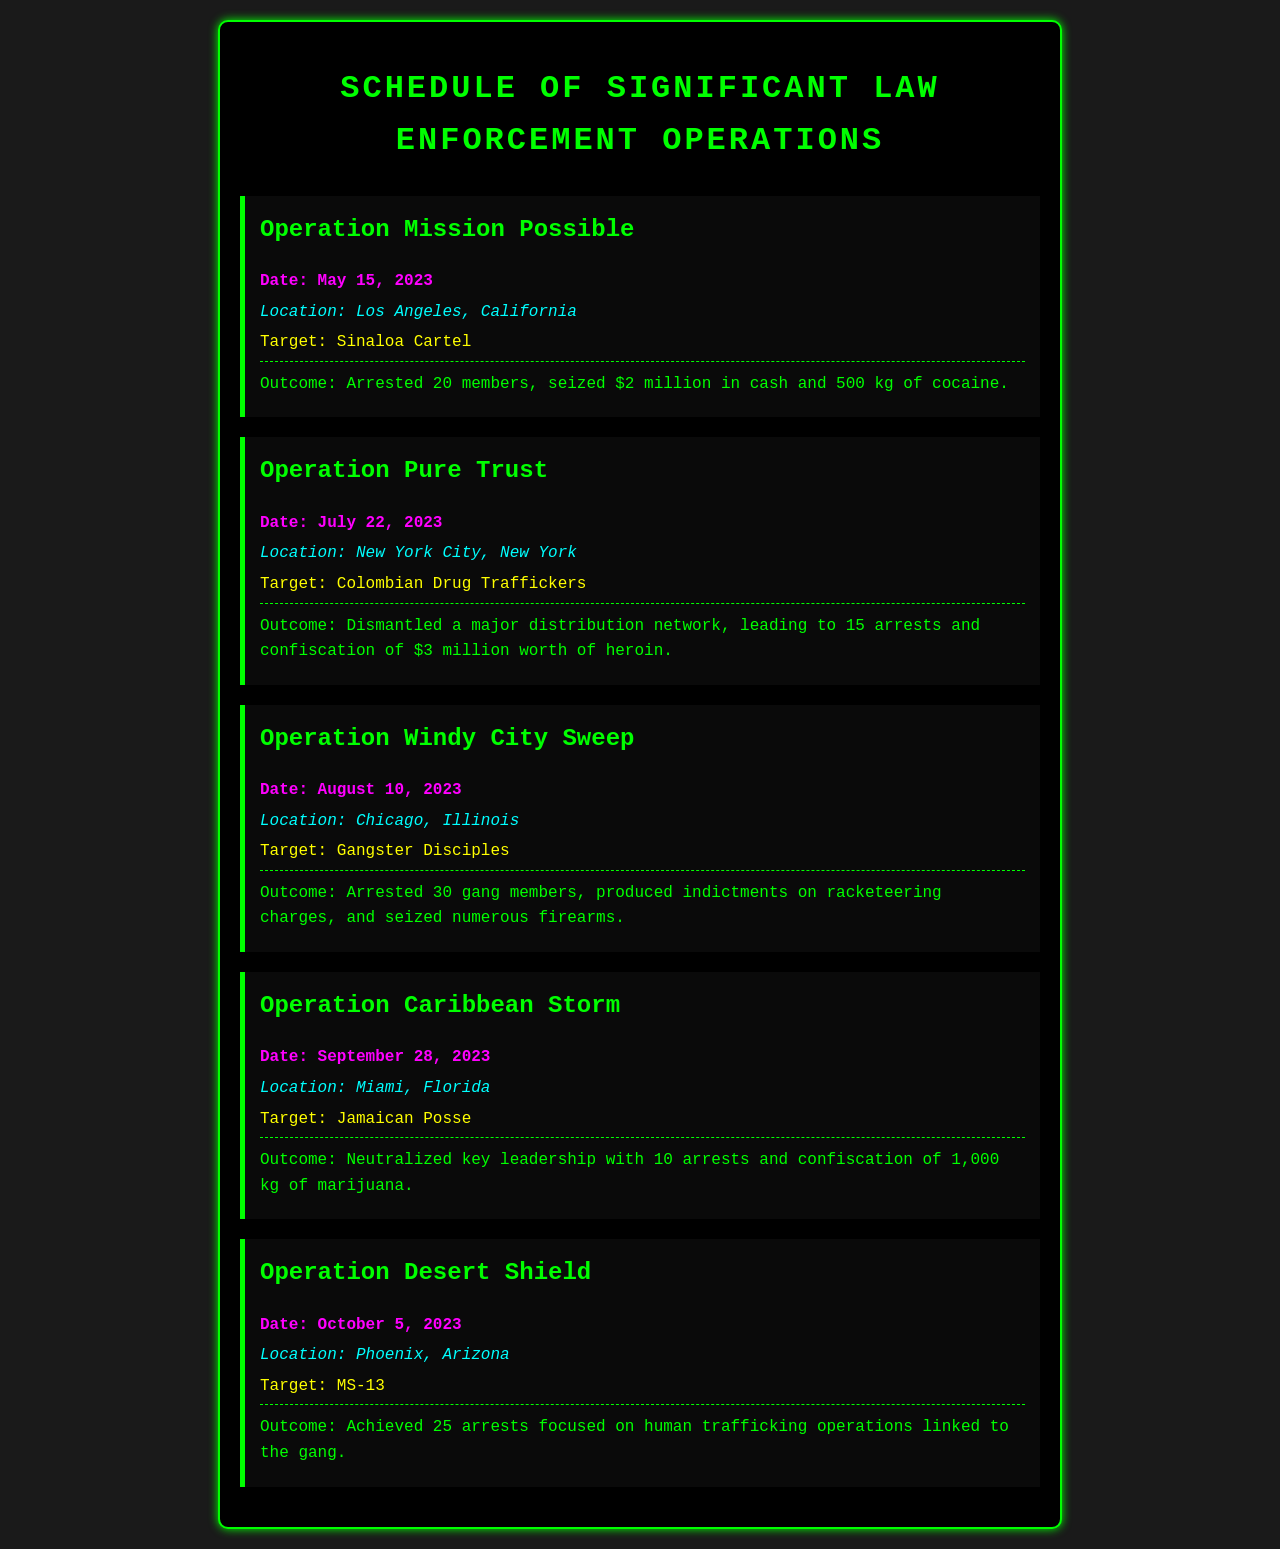What is the date of Operation Mission Possible? The date is explicitly mentioned in the operation details, which is May 15, 2023.
Answer: May 15, 2023 Where did Operation Windy City Sweep take place? The location is specified within the operation details, which states Chicago, Illinois.
Answer: Chicago, Illinois How many gang members were arrested in Operation Windy City Sweep? The number of gang members arrested is clearly listed as 30 in the outcome description.
Answer: 30 What was the target of Operation Caribbean Storm? The document states that the target of the operation was the Jamaican Posse.
Answer: Jamaican Posse Which operation resulted in the confiscation of 1,000 kg of marijuana? The outcome details indicate that Operation Caribbean Storm led to this confiscation.
Answer: Operation Caribbean Storm How much cash was seized in Operation Mission Possible? The amount of cash seized is mentioned as $2 million in the outcome of the operation.
Answer: $2 million What was the total number of arrests made in Operation Pure Trust? The document indicates that there were 15 arrests made in this operation.
Answer: 15 Which operation involved targeting human trafficking linked to MS-13? The operation specifically dealing with this issue is noted as Operation Desert Shield.
Answer: Operation Desert Shield What color is used for the header text in the document? The header text color is indicated to be #00ff00, which is a shade of green.
Answer: Green 